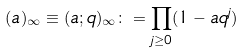<formula> <loc_0><loc_0><loc_500><loc_500>( a ) _ { \infty } \equiv ( a ; q ) _ { \infty } \colon = \prod _ { j \geq 0 } ( 1 - a q ^ { j } )</formula> 